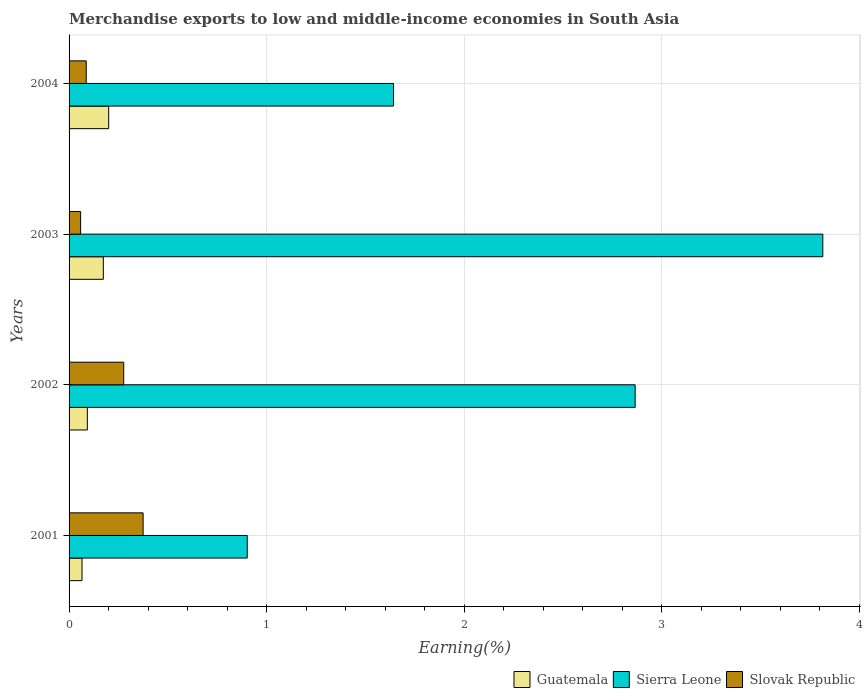How many different coloured bars are there?
Ensure brevity in your answer.  3. How many groups of bars are there?
Provide a succinct answer. 4. How many bars are there on the 1st tick from the top?
Your answer should be very brief. 3. What is the label of the 4th group of bars from the top?
Make the answer very short. 2001. In how many cases, is the number of bars for a given year not equal to the number of legend labels?
Ensure brevity in your answer.  0. What is the percentage of amount earned from merchandise exports in Sierra Leone in 2003?
Give a very brief answer. 3.82. Across all years, what is the maximum percentage of amount earned from merchandise exports in Guatemala?
Your answer should be very brief. 0.2. Across all years, what is the minimum percentage of amount earned from merchandise exports in Sierra Leone?
Provide a succinct answer. 0.9. In which year was the percentage of amount earned from merchandise exports in Slovak Republic maximum?
Make the answer very short. 2001. In which year was the percentage of amount earned from merchandise exports in Slovak Republic minimum?
Provide a succinct answer. 2003. What is the total percentage of amount earned from merchandise exports in Guatemala in the graph?
Make the answer very short. 0.53. What is the difference between the percentage of amount earned from merchandise exports in Slovak Republic in 2001 and that in 2003?
Keep it short and to the point. 0.32. What is the difference between the percentage of amount earned from merchandise exports in Slovak Republic in 2004 and the percentage of amount earned from merchandise exports in Guatemala in 2002?
Your response must be concise. -0.01. What is the average percentage of amount earned from merchandise exports in Slovak Republic per year?
Keep it short and to the point. 0.2. In the year 2001, what is the difference between the percentage of amount earned from merchandise exports in Guatemala and percentage of amount earned from merchandise exports in Sierra Leone?
Ensure brevity in your answer.  -0.84. What is the ratio of the percentage of amount earned from merchandise exports in Sierra Leone in 2001 to that in 2003?
Give a very brief answer. 0.24. Is the percentage of amount earned from merchandise exports in Sierra Leone in 2001 less than that in 2004?
Your answer should be compact. Yes. What is the difference between the highest and the second highest percentage of amount earned from merchandise exports in Sierra Leone?
Make the answer very short. 0.95. What is the difference between the highest and the lowest percentage of amount earned from merchandise exports in Slovak Republic?
Your answer should be compact. 0.32. What does the 3rd bar from the top in 2003 represents?
Give a very brief answer. Guatemala. What does the 2nd bar from the bottom in 2002 represents?
Your response must be concise. Sierra Leone. Is it the case that in every year, the sum of the percentage of amount earned from merchandise exports in Sierra Leone and percentage of amount earned from merchandise exports in Slovak Republic is greater than the percentage of amount earned from merchandise exports in Guatemala?
Make the answer very short. Yes. How many bars are there?
Provide a succinct answer. 12. Are the values on the major ticks of X-axis written in scientific E-notation?
Provide a succinct answer. No. Does the graph contain grids?
Offer a terse response. Yes. Where does the legend appear in the graph?
Offer a very short reply. Bottom right. How are the legend labels stacked?
Your answer should be very brief. Horizontal. What is the title of the graph?
Keep it short and to the point. Merchandise exports to low and middle-income economies in South Asia. What is the label or title of the X-axis?
Keep it short and to the point. Earning(%). What is the Earning(%) of Guatemala in 2001?
Ensure brevity in your answer.  0.07. What is the Earning(%) of Sierra Leone in 2001?
Offer a very short reply. 0.9. What is the Earning(%) of Slovak Republic in 2001?
Offer a very short reply. 0.37. What is the Earning(%) in Guatemala in 2002?
Provide a short and direct response. 0.09. What is the Earning(%) of Sierra Leone in 2002?
Offer a terse response. 2.87. What is the Earning(%) in Slovak Republic in 2002?
Your response must be concise. 0.28. What is the Earning(%) in Guatemala in 2003?
Your answer should be compact. 0.17. What is the Earning(%) of Sierra Leone in 2003?
Offer a very short reply. 3.82. What is the Earning(%) of Slovak Republic in 2003?
Provide a short and direct response. 0.06. What is the Earning(%) of Guatemala in 2004?
Make the answer very short. 0.2. What is the Earning(%) of Sierra Leone in 2004?
Offer a terse response. 1.64. What is the Earning(%) in Slovak Republic in 2004?
Your response must be concise. 0.09. Across all years, what is the maximum Earning(%) of Guatemala?
Make the answer very short. 0.2. Across all years, what is the maximum Earning(%) of Sierra Leone?
Provide a succinct answer. 3.82. Across all years, what is the maximum Earning(%) of Slovak Republic?
Ensure brevity in your answer.  0.37. Across all years, what is the minimum Earning(%) of Guatemala?
Offer a very short reply. 0.07. Across all years, what is the minimum Earning(%) in Sierra Leone?
Ensure brevity in your answer.  0.9. Across all years, what is the minimum Earning(%) in Slovak Republic?
Offer a very short reply. 0.06. What is the total Earning(%) in Guatemala in the graph?
Give a very brief answer. 0.53. What is the total Earning(%) of Sierra Leone in the graph?
Offer a very short reply. 9.23. What is the total Earning(%) in Slovak Republic in the graph?
Your response must be concise. 0.8. What is the difference between the Earning(%) in Guatemala in 2001 and that in 2002?
Offer a very short reply. -0.03. What is the difference between the Earning(%) of Sierra Leone in 2001 and that in 2002?
Your answer should be compact. -1.96. What is the difference between the Earning(%) of Slovak Republic in 2001 and that in 2002?
Keep it short and to the point. 0.1. What is the difference between the Earning(%) in Guatemala in 2001 and that in 2003?
Your answer should be very brief. -0.11. What is the difference between the Earning(%) in Sierra Leone in 2001 and that in 2003?
Your answer should be compact. -2.91. What is the difference between the Earning(%) of Slovak Republic in 2001 and that in 2003?
Your answer should be compact. 0.32. What is the difference between the Earning(%) in Guatemala in 2001 and that in 2004?
Make the answer very short. -0.14. What is the difference between the Earning(%) of Sierra Leone in 2001 and that in 2004?
Make the answer very short. -0.74. What is the difference between the Earning(%) in Slovak Republic in 2001 and that in 2004?
Your answer should be very brief. 0.29. What is the difference between the Earning(%) of Guatemala in 2002 and that in 2003?
Ensure brevity in your answer.  -0.08. What is the difference between the Earning(%) of Sierra Leone in 2002 and that in 2003?
Offer a terse response. -0.95. What is the difference between the Earning(%) of Slovak Republic in 2002 and that in 2003?
Offer a very short reply. 0.22. What is the difference between the Earning(%) of Guatemala in 2002 and that in 2004?
Ensure brevity in your answer.  -0.11. What is the difference between the Earning(%) of Sierra Leone in 2002 and that in 2004?
Ensure brevity in your answer.  1.22. What is the difference between the Earning(%) in Slovak Republic in 2002 and that in 2004?
Your answer should be very brief. 0.19. What is the difference between the Earning(%) of Guatemala in 2003 and that in 2004?
Your answer should be compact. -0.03. What is the difference between the Earning(%) of Sierra Leone in 2003 and that in 2004?
Keep it short and to the point. 2.17. What is the difference between the Earning(%) of Slovak Republic in 2003 and that in 2004?
Your answer should be compact. -0.03. What is the difference between the Earning(%) in Guatemala in 2001 and the Earning(%) in Sierra Leone in 2002?
Your answer should be very brief. -2.8. What is the difference between the Earning(%) in Guatemala in 2001 and the Earning(%) in Slovak Republic in 2002?
Offer a very short reply. -0.21. What is the difference between the Earning(%) in Sierra Leone in 2001 and the Earning(%) in Slovak Republic in 2002?
Offer a very short reply. 0.63. What is the difference between the Earning(%) of Guatemala in 2001 and the Earning(%) of Sierra Leone in 2003?
Keep it short and to the point. -3.75. What is the difference between the Earning(%) in Guatemala in 2001 and the Earning(%) in Slovak Republic in 2003?
Ensure brevity in your answer.  0.01. What is the difference between the Earning(%) of Sierra Leone in 2001 and the Earning(%) of Slovak Republic in 2003?
Keep it short and to the point. 0.84. What is the difference between the Earning(%) in Guatemala in 2001 and the Earning(%) in Sierra Leone in 2004?
Your answer should be very brief. -1.58. What is the difference between the Earning(%) of Guatemala in 2001 and the Earning(%) of Slovak Republic in 2004?
Provide a short and direct response. -0.02. What is the difference between the Earning(%) in Sierra Leone in 2001 and the Earning(%) in Slovak Republic in 2004?
Your answer should be very brief. 0.82. What is the difference between the Earning(%) in Guatemala in 2002 and the Earning(%) in Sierra Leone in 2003?
Keep it short and to the point. -3.72. What is the difference between the Earning(%) of Guatemala in 2002 and the Earning(%) of Slovak Republic in 2003?
Ensure brevity in your answer.  0.03. What is the difference between the Earning(%) of Sierra Leone in 2002 and the Earning(%) of Slovak Republic in 2003?
Your answer should be compact. 2.81. What is the difference between the Earning(%) in Guatemala in 2002 and the Earning(%) in Sierra Leone in 2004?
Keep it short and to the point. -1.55. What is the difference between the Earning(%) in Guatemala in 2002 and the Earning(%) in Slovak Republic in 2004?
Ensure brevity in your answer.  0.01. What is the difference between the Earning(%) of Sierra Leone in 2002 and the Earning(%) of Slovak Republic in 2004?
Your response must be concise. 2.78. What is the difference between the Earning(%) of Guatemala in 2003 and the Earning(%) of Sierra Leone in 2004?
Keep it short and to the point. -1.47. What is the difference between the Earning(%) of Guatemala in 2003 and the Earning(%) of Slovak Republic in 2004?
Keep it short and to the point. 0.09. What is the difference between the Earning(%) of Sierra Leone in 2003 and the Earning(%) of Slovak Republic in 2004?
Your answer should be very brief. 3.73. What is the average Earning(%) of Guatemala per year?
Provide a short and direct response. 0.13. What is the average Earning(%) in Sierra Leone per year?
Your response must be concise. 2.31. What is the average Earning(%) of Slovak Republic per year?
Your answer should be compact. 0.2. In the year 2001, what is the difference between the Earning(%) of Guatemala and Earning(%) of Sierra Leone?
Provide a short and direct response. -0.84. In the year 2001, what is the difference between the Earning(%) in Guatemala and Earning(%) in Slovak Republic?
Offer a very short reply. -0.31. In the year 2001, what is the difference between the Earning(%) of Sierra Leone and Earning(%) of Slovak Republic?
Provide a short and direct response. 0.53. In the year 2002, what is the difference between the Earning(%) of Guatemala and Earning(%) of Sierra Leone?
Your answer should be very brief. -2.77. In the year 2002, what is the difference between the Earning(%) in Guatemala and Earning(%) in Slovak Republic?
Give a very brief answer. -0.18. In the year 2002, what is the difference between the Earning(%) of Sierra Leone and Earning(%) of Slovak Republic?
Provide a succinct answer. 2.59. In the year 2003, what is the difference between the Earning(%) in Guatemala and Earning(%) in Sierra Leone?
Give a very brief answer. -3.64. In the year 2003, what is the difference between the Earning(%) in Guatemala and Earning(%) in Slovak Republic?
Make the answer very short. 0.12. In the year 2003, what is the difference between the Earning(%) in Sierra Leone and Earning(%) in Slovak Republic?
Provide a succinct answer. 3.76. In the year 2004, what is the difference between the Earning(%) in Guatemala and Earning(%) in Sierra Leone?
Offer a terse response. -1.44. In the year 2004, what is the difference between the Earning(%) of Guatemala and Earning(%) of Slovak Republic?
Make the answer very short. 0.11. In the year 2004, what is the difference between the Earning(%) in Sierra Leone and Earning(%) in Slovak Republic?
Your answer should be compact. 1.56. What is the ratio of the Earning(%) in Guatemala in 2001 to that in 2002?
Give a very brief answer. 0.71. What is the ratio of the Earning(%) in Sierra Leone in 2001 to that in 2002?
Your response must be concise. 0.31. What is the ratio of the Earning(%) in Slovak Republic in 2001 to that in 2002?
Your answer should be compact. 1.36. What is the ratio of the Earning(%) in Guatemala in 2001 to that in 2003?
Give a very brief answer. 0.38. What is the ratio of the Earning(%) in Sierra Leone in 2001 to that in 2003?
Make the answer very short. 0.24. What is the ratio of the Earning(%) in Slovak Republic in 2001 to that in 2003?
Keep it short and to the point. 6.42. What is the ratio of the Earning(%) of Guatemala in 2001 to that in 2004?
Give a very brief answer. 0.33. What is the ratio of the Earning(%) of Sierra Leone in 2001 to that in 2004?
Offer a very short reply. 0.55. What is the ratio of the Earning(%) of Slovak Republic in 2001 to that in 2004?
Offer a very short reply. 4.32. What is the ratio of the Earning(%) of Guatemala in 2002 to that in 2003?
Your answer should be compact. 0.53. What is the ratio of the Earning(%) of Sierra Leone in 2002 to that in 2003?
Offer a terse response. 0.75. What is the ratio of the Earning(%) of Slovak Republic in 2002 to that in 2003?
Provide a succinct answer. 4.73. What is the ratio of the Earning(%) of Guatemala in 2002 to that in 2004?
Make the answer very short. 0.46. What is the ratio of the Earning(%) in Sierra Leone in 2002 to that in 2004?
Your answer should be very brief. 1.74. What is the ratio of the Earning(%) in Slovak Republic in 2002 to that in 2004?
Ensure brevity in your answer.  3.19. What is the ratio of the Earning(%) in Guatemala in 2003 to that in 2004?
Offer a very short reply. 0.86. What is the ratio of the Earning(%) in Sierra Leone in 2003 to that in 2004?
Ensure brevity in your answer.  2.32. What is the ratio of the Earning(%) in Slovak Republic in 2003 to that in 2004?
Keep it short and to the point. 0.67. What is the difference between the highest and the second highest Earning(%) in Guatemala?
Keep it short and to the point. 0.03. What is the difference between the highest and the second highest Earning(%) in Sierra Leone?
Provide a succinct answer. 0.95. What is the difference between the highest and the second highest Earning(%) in Slovak Republic?
Offer a very short reply. 0.1. What is the difference between the highest and the lowest Earning(%) of Guatemala?
Ensure brevity in your answer.  0.14. What is the difference between the highest and the lowest Earning(%) of Sierra Leone?
Offer a terse response. 2.91. What is the difference between the highest and the lowest Earning(%) in Slovak Republic?
Offer a terse response. 0.32. 